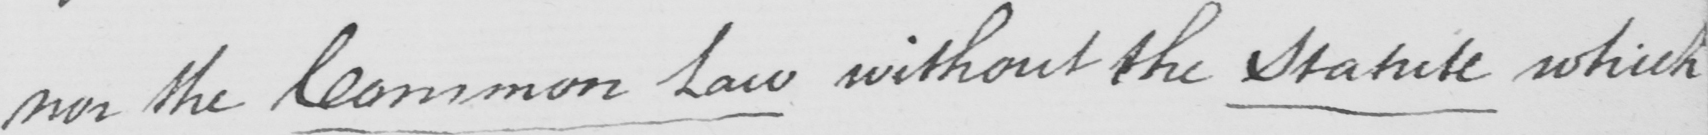What text is written in this handwritten line? nor the Common Law without the Statute which 